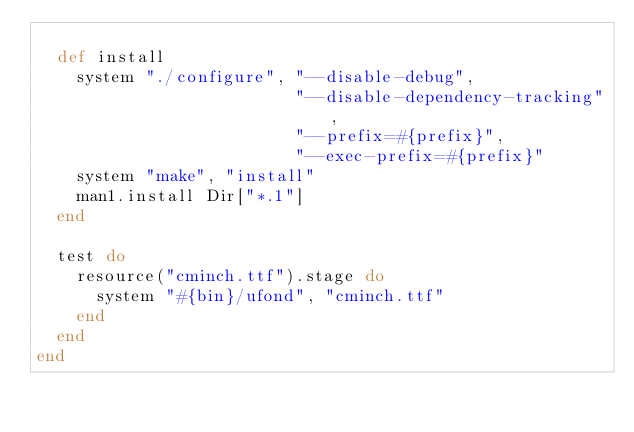Convert code to text. <code><loc_0><loc_0><loc_500><loc_500><_Ruby_>
  def install
    system "./configure", "--disable-debug",
                          "--disable-dependency-tracking",
                          "--prefix=#{prefix}",
                          "--exec-prefix=#{prefix}"
    system "make", "install"
    man1.install Dir["*.1"]
  end

  test do
    resource("cminch.ttf").stage do
      system "#{bin}/ufond", "cminch.ttf"
    end
  end
end
</code> 